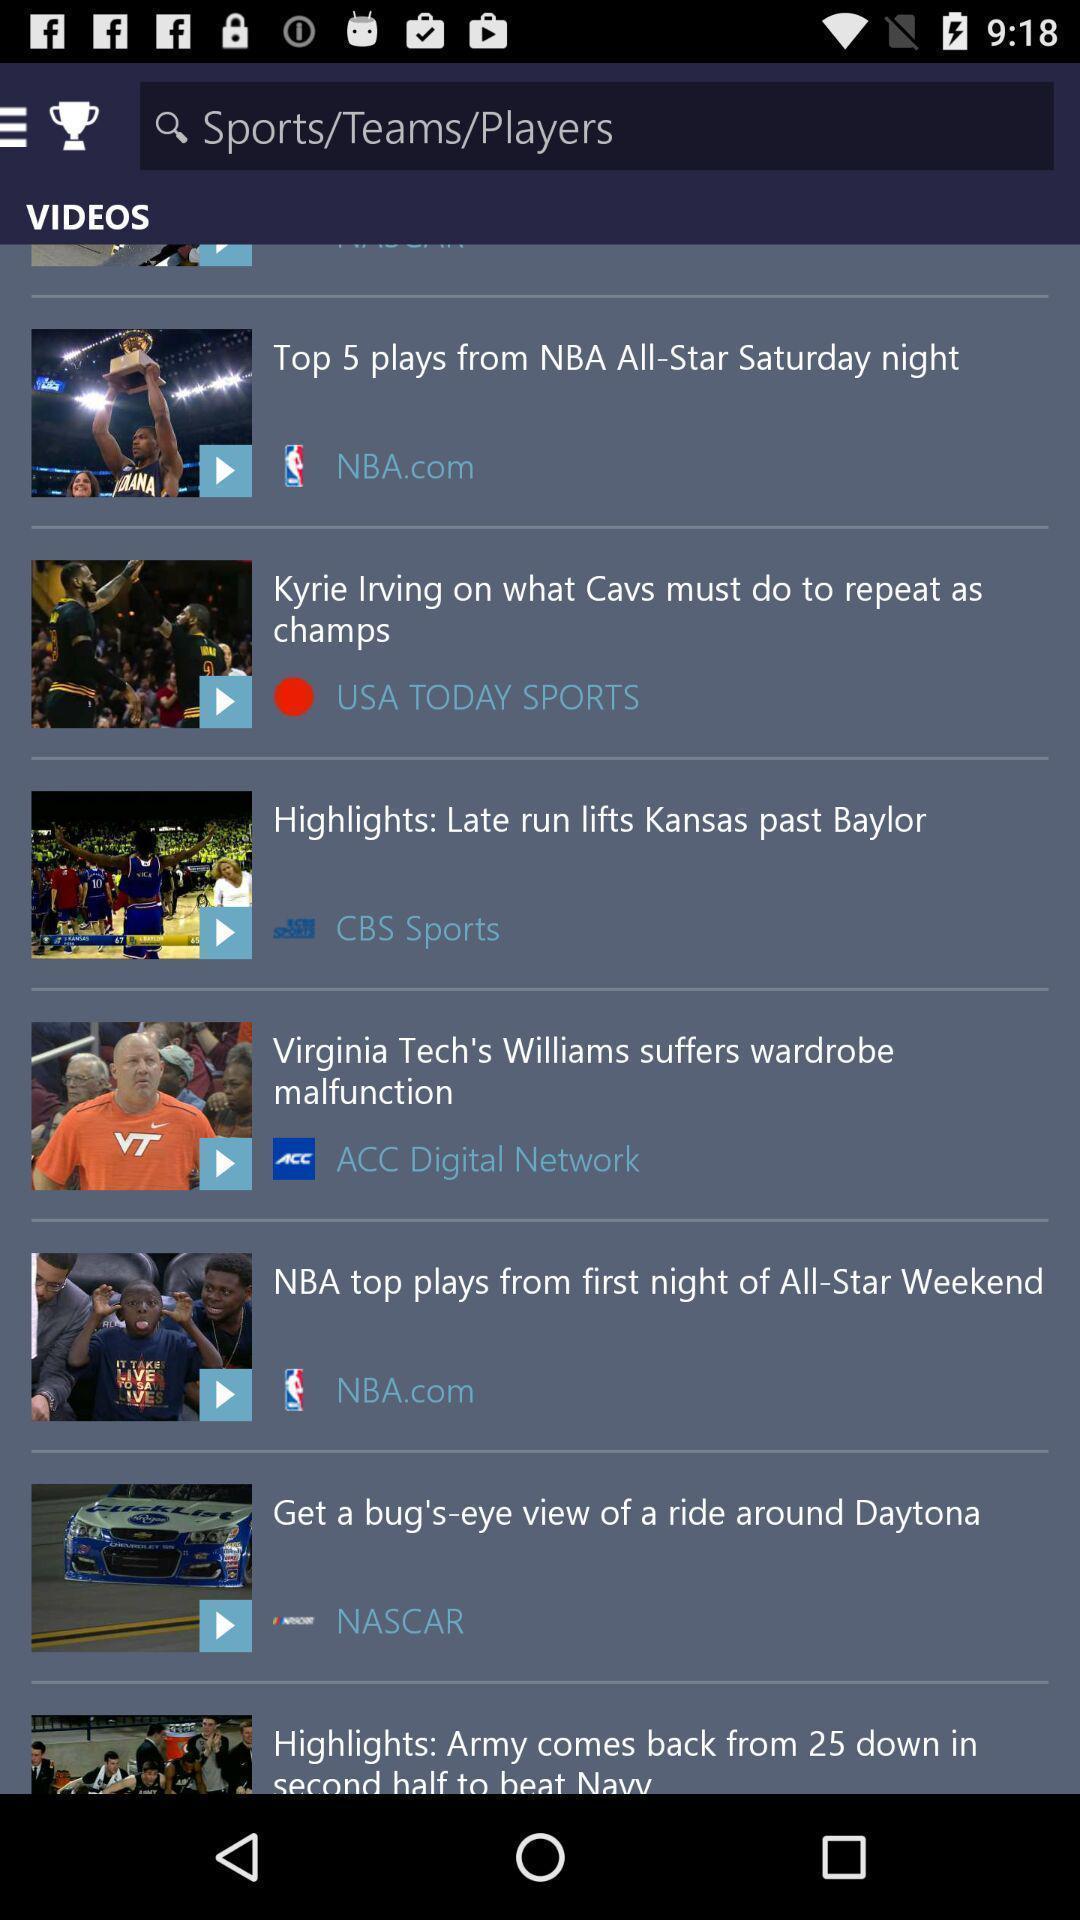Summarize the main components in this picture. Search bar of a sports application showing list of videos. 